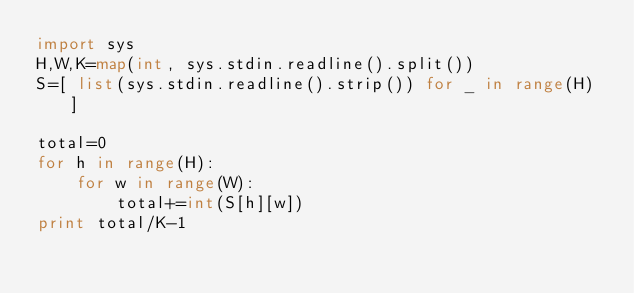Convert code to text. <code><loc_0><loc_0><loc_500><loc_500><_Python_>import sys
H,W,K=map(int, sys.stdin.readline().split())
S=[ list(sys.stdin.readline().strip()) for _ in range(H) ]

total=0
for h in range(H):
    for w in range(W):
        total+=int(S[h][w])
print total/K-1</code> 